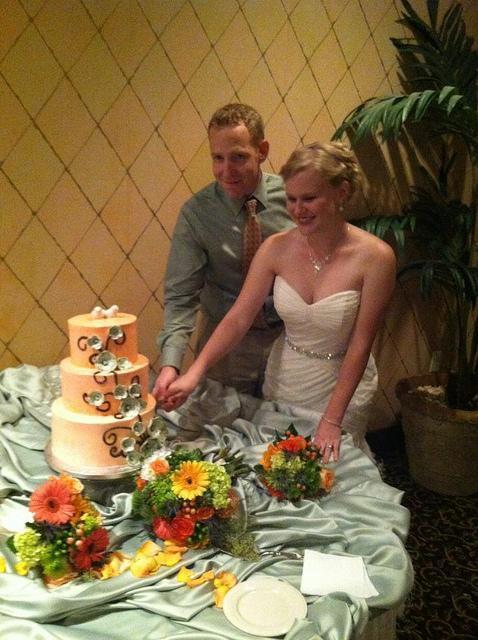How many people can you see?
Give a very brief answer. 2. How many potted plants are there?
Give a very brief answer. 3. 